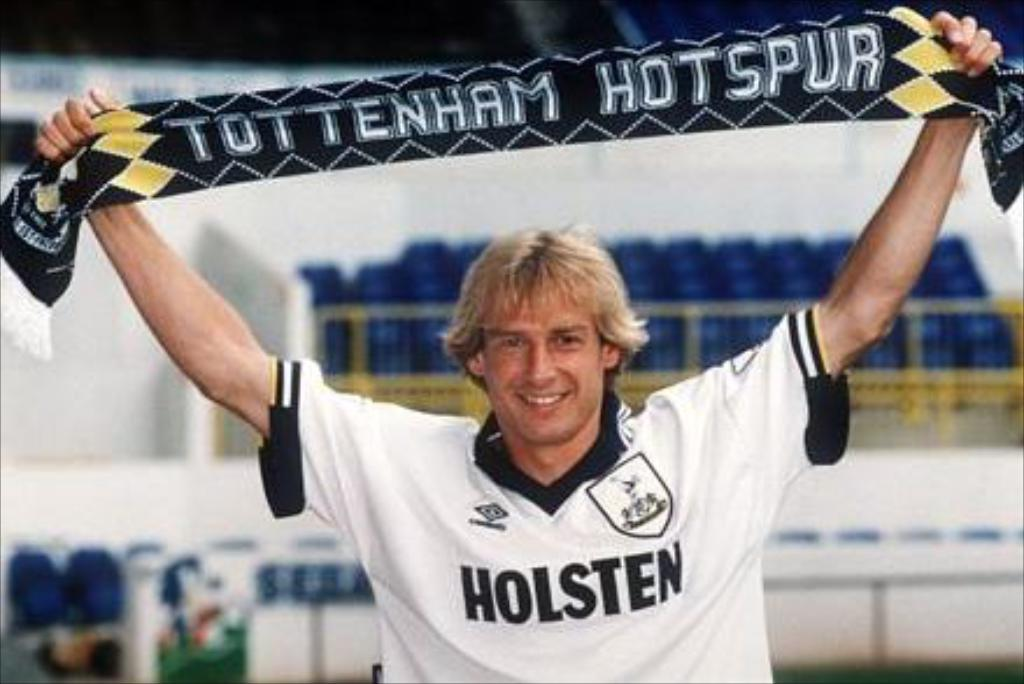What is the main subject of the image? There is a person standing in the center of the image. What is the person holding in the image? The person is holding a cloth. What can be seen in the background of the image? There are chairs and a wall in the background of the image. What is the person's desire or request in the image? There is no indication of the person's desire or request in the image. Can you tell me how fast the person is running in the image? The person is not running in the image; they are standing still. 